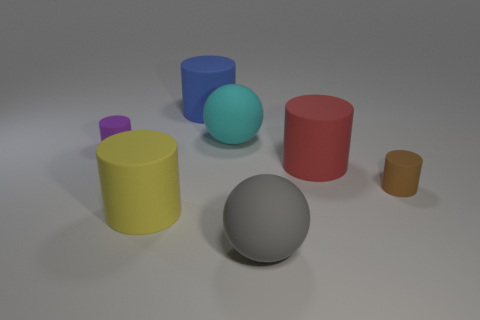Add 1 tiny green things. How many objects exist? 8 Subtract all yellow cylinders. How many cylinders are left? 4 Subtract 0 purple cubes. How many objects are left? 7 Subtract all balls. How many objects are left? 5 Subtract 2 cylinders. How many cylinders are left? 3 Subtract all gray cylinders. Subtract all gray spheres. How many cylinders are left? 5 Subtract all purple spheres. How many cyan cylinders are left? 0 Subtract all brown matte cylinders. Subtract all small brown rubber objects. How many objects are left? 5 Add 7 gray rubber objects. How many gray rubber objects are left? 8 Add 1 big spheres. How many big spheres exist? 3 